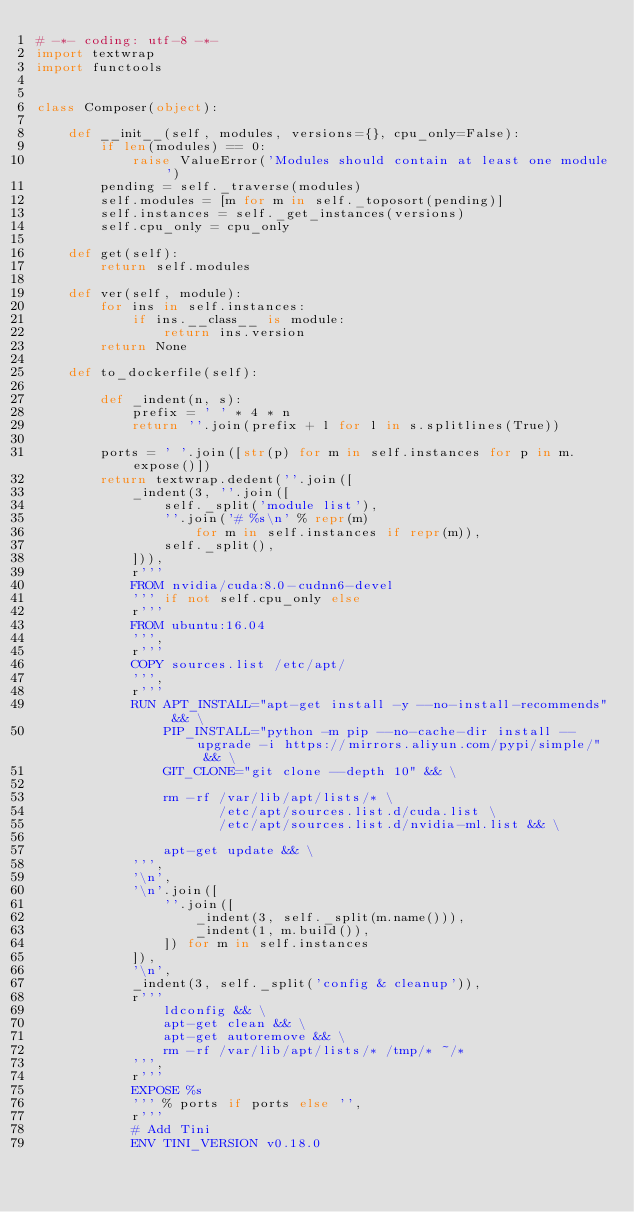<code> <loc_0><loc_0><loc_500><loc_500><_Python_># -*- coding: utf-8 -*-
import textwrap
import functools


class Composer(object):

    def __init__(self, modules, versions={}, cpu_only=False):
        if len(modules) == 0:
            raise ValueError('Modules should contain at least one module')
        pending = self._traverse(modules)
        self.modules = [m for m in self._toposort(pending)]
        self.instances = self._get_instances(versions)
        self.cpu_only = cpu_only

    def get(self):
        return self.modules

    def ver(self, module):
        for ins in self.instances:
            if ins.__class__ is module:
                return ins.version
        return None

    def to_dockerfile(self):

        def _indent(n, s):
            prefix = ' ' * 4 * n
            return ''.join(prefix + l for l in s.splitlines(True))

        ports = ' '.join([str(p) for m in self.instances for p in m.expose()])
        return textwrap.dedent(''.join([
            _indent(3, ''.join([
                self._split('module list'),
                ''.join('# %s\n' % repr(m)
                    for m in self.instances if repr(m)),
                self._split(),
            ])),
            r'''
            FROM nvidia/cuda:8.0-cudnn6-devel
            ''' if not self.cpu_only else
            r'''
            FROM ubuntu:16.04
            ''',
            r'''
            COPY sources.list /etc/apt/
            ''',
            r'''
            RUN APT_INSTALL="apt-get install -y --no-install-recommends" && \
                PIP_INSTALL="python -m pip --no-cache-dir install --upgrade -i https://mirrors.aliyun.com/pypi/simple/" && \
                GIT_CLONE="git clone --depth 10" && \

                rm -rf /var/lib/apt/lists/* \
                       /etc/apt/sources.list.d/cuda.list \
                       /etc/apt/sources.list.d/nvidia-ml.list && \

                apt-get update && \
            ''',
            '\n',
            '\n'.join([
                ''.join([
                    _indent(3, self._split(m.name())),
                    _indent(1, m.build()),
                ]) for m in self.instances
            ]),
            '\n',
            _indent(3, self._split('config & cleanup')),
            r'''
                ldconfig && \
                apt-get clean && \
                apt-get autoremove && \
                rm -rf /var/lib/apt/lists/* /tmp/* ~/*
            ''',
            r'''
            EXPOSE %s
            ''' % ports if ports else '',
            r'''
            # Add Tini
            ENV TINI_VERSION v0.18.0</code> 